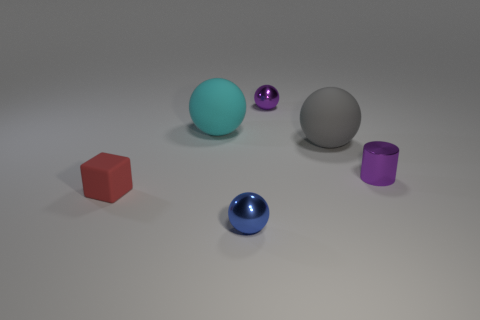Is the size of the gray thing the same as the shiny ball that is left of the purple ball?
Offer a terse response. No. What number of cyan objects are either balls or small matte blocks?
Keep it short and to the point. 1. How many shiny cylinders are there?
Your answer should be very brief. 1. What size is the purple metallic object that is in front of the big gray rubber object?
Your response must be concise. Small. Is the size of the red matte object the same as the cylinder?
Offer a terse response. Yes. How many objects are either large matte objects or small things on the right side of the block?
Offer a very short reply. 5. What is the cylinder made of?
Your response must be concise. Metal. Are there any other things of the same color as the tiny shiny cylinder?
Offer a very short reply. Yes. Is the tiny red object the same shape as the small blue metallic thing?
Provide a succinct answer. No. What is the size of the metallic sphere behind the shiny ball that is in front of the matte object that is right of the big cyan rubber ball?
Provide a short and direct response. Small. 